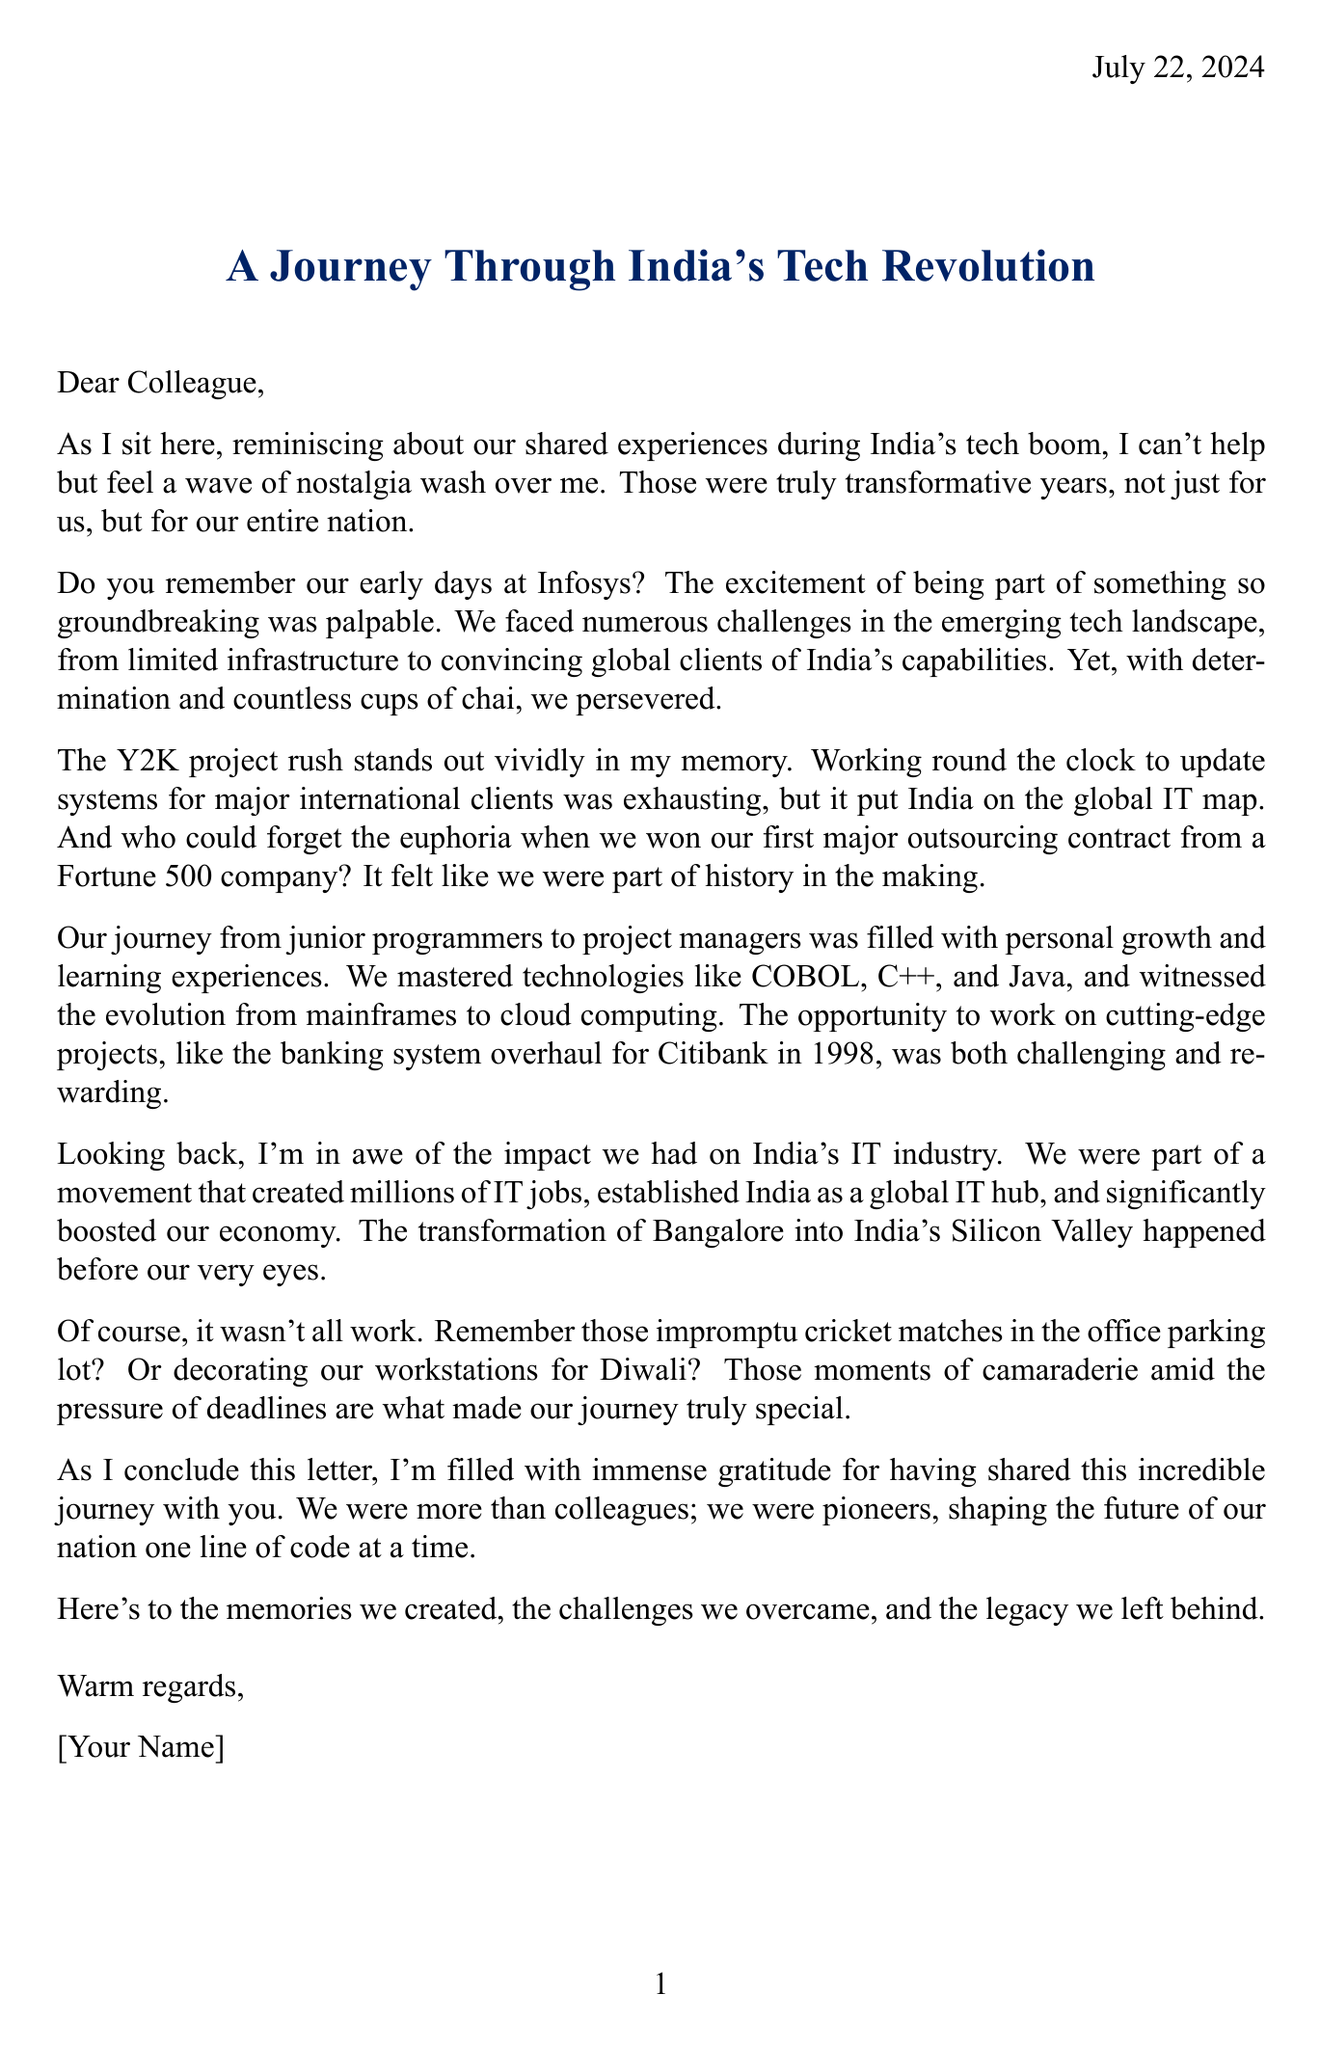What was the first major outsourcing contract celebrated? The document mentions celebrating the win of a significant project from a Fortune 500 company as the first major outsourcing contract.
Answer: Fortune 500 company Who is the co-founder of Infosys mentioned in the letter? Narayana Murthy is stated as the co-founder of Infosys in the document.
Answer: Narayana Murthy What year did the banking system overhaul for Citibank take place? The letter states that the banking system overhaul for Citibank occurred in 1998.
Answer: 1998 Which technologies were mastered during the tech boom? The document lists several technologies including COBOL, C++, and Java as technologies mastered during the tech boom.
Answer: COBOL, C++, Java What significant impact did the IT industry have on India's economy? The letter mentions that the IT industry significantly boosted India's economy through foreign exchange earnings.
Answer: Boost to the economy What nostalgic moment is related to office celebrations? The document describes decorating workstations for Diwali as a nostalgic moment related to office celebrations.
Answer: Decorating our workstations for Diwali How did the colleagues transition in their careers? The letter states that there was a transition from junior programmers to project managers over time.
Answer: Junior programmers to project managers What facility opening is mentioned in the letter? The opening of a new tech park in Bangalore's Electronic City is noted in the document.
Answer: New tech park in Bangalore's Electronic City 